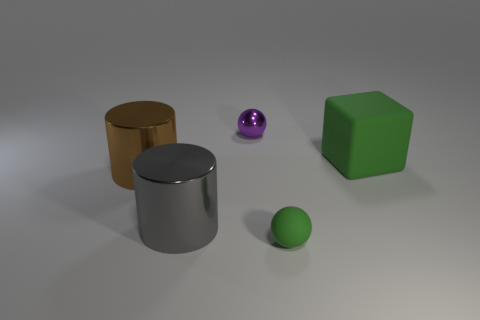Subtract all balls. How many objects are left? 3 Add 2 big green objects. How many objects exist? 7 Add 1 big matte objects. How many big matte objects are left? 2 Add 1 brown cylinders. How many brown cylinders exist? 2 Subtract all purple spheres. How many spheres are left? 1 Subtract 0 yellow spheres. How many objects are left? 5 Subtract 1 cylinders. How many cylinders are left? 1 Subtract all purple spheres. Subtract all blue cylinders. How many spheres are left? 1 Subtract all brown cylinders. How many purple blocks are left? 0 Subtract all large gray metallic objects. Subtract all tiny shiny objects. How many objects are left? 3 